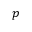<formula> <loc_0><loc_0><loc_500><loc_500>p</formula> 